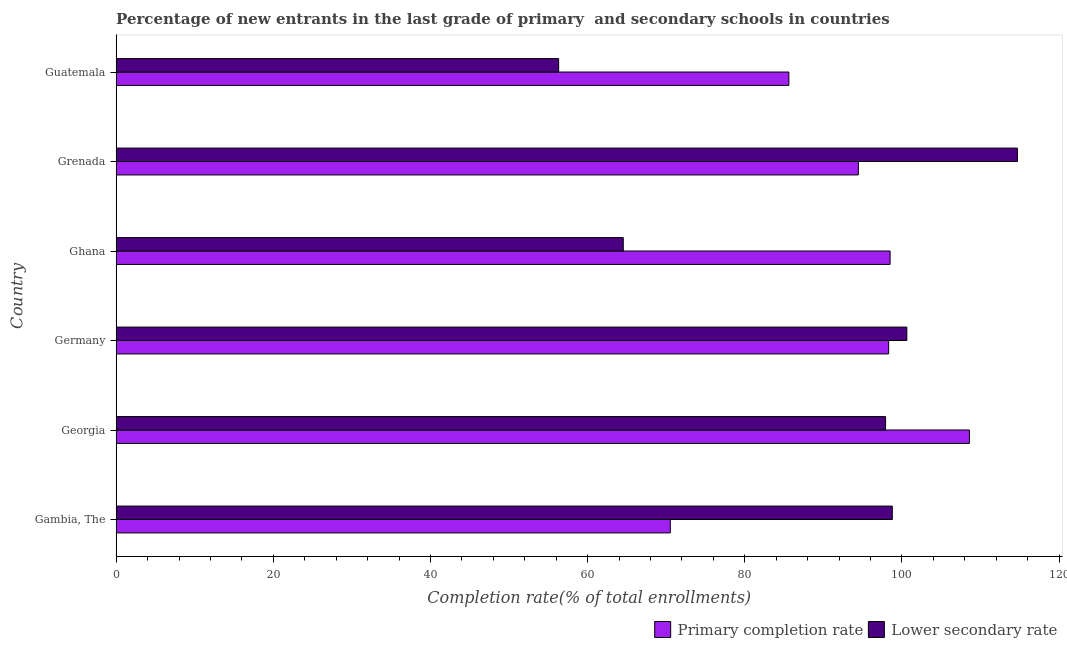How many different coloured bars are there?
Your answer should be compact. 2. Are the number of bars per tick equal to the number of legend labels?
Give a very brief answer. Yes. How many bars are there on the 2nd tick from the bottom?
Provide a short and direct response. 2. What is the label of the 1st group of bars from the top?
Offer a very short reply. Guatemala. What is the completion rate in secondary schools in Georgia?
Your response must be concise. 97.92. Across all countries, what is the maximum completion rate in primary schools?
Your response must be concise. 108.59. Across all countries, what is the minimum completion rate in primary schools?
Provide a short and direct response. 70.52. In which country was the completion rate in primary schools maximum?
Provide a succinct answer. Georgia. In which country was the completion rate in primary schools minimum?
Ensure brevity in your answer.  Gambia, The. What is the total completion rate in primary schools in the graph?
Your answer should be compact. 556. What is the difference between the completion rate in primary schools in Ghana and that in Guatemala?
Provide a short and direct response. 12.88. What is the difference between the completion rate in secondary schools in Grenada and the completion rate in primary schools in Georgia?
Ensure brevity in your answer.  6.11. What is the average completion rate in secondary schools per country?
Ensure brevity in your answer.  88.81. What is the difference between the completion rate in secondary schools and completion rate in primary schools in Georgia?
Make the answer very short. -10.67. What is the ratio of the completion rate in primary schools in Georgia to that in Guatemala?
Your answer should be compact. 1.27. Is the difference between the completion rate in secondary schools in Georgia and Germany greater than the difference between the completion rate in primary schools in Georgia and Germany?
Keep it short and to the point. No. What is the difference between the highest and the second highest completion rate in primary schools?
Your response must be concise. 10.1. What is the difference between the highest and the lowest completion rate in primary schools?
Your answer should be compact. 38.07. In how many countries, is the completion rate in secondary schools greater than the average completion rate in secondary schools taken over all countries?
Offer a terse response. 4. What does the 2nd bar from the top in Grenada represents?
Provide a short and direct response. Primary completion rate. What does the 1st bar from the bottom in Georgia represents?
Your answer should be compact. Primary completion rate. How many bars are there?
Make the answer very short. 12. How many countries are there in the graph?
Your answer should be compact. 6. What is the difference between two consecutive major ticks on the X-axis?
Keep it short and to the point. 20. Does the graph contain any zero values?
Provide a short and direct response. No. Does the graph contain grids?
Your answer should be compact. No. Where does the legend appear in the graph?
Provide a short and direct response. Bottom right. How are the legend labels stacked?
Provide a short and direct response. Horizontal. What is the title of the graph?
Make the answer very short. Percentage of new entrants in the last grade of primary  and secondary schools in countries. What is the label or title of the X-axis?
Keep it short and to the point. Completion rate(% of total enrollments). What is the label or title of the Y-axis?
Your answer should be compact. Country. What is the Completion rate(% of total enrollments) of Primary completion rate in Gambia, The?
Provide a short and direct response. 70.52. What is the Completion rate(% of total enrollments) in Lower secondary rate in Gambia, The?
Give a very brief answer. 98.78. What is the Completion rate(% of total enrollments) of Primary completion rate in Georgia?
Provide a short and direct response. 108.59. What is the Completion rate(% of total enrollments) of Lower secondary rate in Georgia?
Provide a succinct answer. 97.92. What is the Completion rate(% of total enrollments) of Primary completion rate in Germany?
Ensure brevity in your answer.  98.32. What is the Completion rate(% of total enrollments) of Lower secondary rate in Germany?
Keep it short and to the point. 100.63. What is the Completion rate(% of total enrollments) in Primary completion rate in Ghana?
Make the answer very short. 98.5. What is the Completion rate(% of total enrollments) in Lower secondary rate in Ghana?
Provide a short and direct response. 64.54. What is the Completion rate(% of total enrollments) of Primary completion rate in Grenada?
Your response must be concise. 94.46. What is the Completion rate(% of total enrollments) of Lower secondary rate in Grenada?
Make the answer very short. 114.7. What is the Completion rate(% of total enrollments) in Primary completion rate in Guatemala?
Your answer should be very brief. 85.61. What is the Completion rate(% of total enrollments) in Lower secondary rate in Guatemala?
Your answer should be compact. 56.32. Across all countries, what is the maximum Completion rate(% of total enrollments) of Primary completion rate?
Offer a very short reply. 108.59. Across all countries, what is the maximum Completion rate(% of total enrollments) in Lower secondary rate?
Offer a terse response. 114.7. Across all countries, what is the minimum Completion rate(% of total enrollments) in Primary completion rate?
Ensure brevity in your answer.  70.52. Across all countries, what is the minimum Completion rate(% of total enrollments) of Lower secondary rate?
Your answer should be compact. 56.32. What is the total Completion rate(% of total enrollments) of Primary completion rate in the graph?
Your answer should be very brief. 556. What is the total Completion rate(% of total enrollments) in Lower secondary rate in the graph?
Provide a short and direct response. 532.88. What is the difference between the Completion rate(% of total enrollments) of Primary completion rate in Gambia, The and that in Georgia?
Give a very brief answer. -38.07. What is the difference between the Completion rate(% of total enrollments) in Lower secondary rate in Gambia, The and that in Georgia?
Your answer should be compact. 0.86. What is the difference between the Completion rate(% of total enrollments) in Primary completion rate in Gambia, The and that in Germany?
Provide a short and direct response. -27.79. What is the difference between the Completion rate(% of total enrollments) of Lower secondary rate in Gambia, The and that in Germany?
Your response must be concise. -1.85. What is the difference between the Completion rate(% of total enrollments) of Primary completion rate in Gambia, The and that in Ghana?
Provide a succinct answer. -27.97. What is the difference between the Completion rate(% of total enrollments) of Lower secondary rate in Gambia, The and that in Ghana?
Your answer should be compact. 34.24. What is the difference between the Completion rate(% of total enrollments) of Primary completion rate in Gambia, The and that in Grenada?
Provide a short and direct response. -23.94. What is the difference between the Completion rate(% of total enrollments) of Lower secondary rate in Gambia, The and that in Grenada?
Your answer should be compact. -15.92. What is the difference between the Completion rate(% of total enrollments) of Primary completion rate in Gambia, The and that in Guatemala?
Offer a very short reply. -15.09. What is the difference between the Completion rate(% of total enrollments) in Lower secondary rate in Gambia, The and that in Guatemala?
Your answer should be compact. 42.46. What is the difference between the Completion rate(% of total enrollments) in Primary completion rate in Georgia and that in Germany?
Your response must be concise. 10.28. What is the difference between the Completion rate(% of total enrollments) of Lower secondary rate in Georgia and that in Germany?
Make the answer very short. -2.71. What is the difference between the Completion rate(% of total enrollments) in Primary completion rate in Georgia and that in Ghana?
Your answer should be compact. 10.1. What is the difference between the Completion rate(% of total enrollments) in Lower secondary rate in Georgia and that in Ghana?
Give a very brief answer. 33.38. What is the difference between the Completion rate(% of total enrollments) of Primary completion rate in Georgia and that in Grenada?
Keep it short and to the point. 14.13. What is the difference between the Completion rate(% of total enrollments) of Lower secondary rate in Georgia and that in Grenada?
Ensure brevity in your answer.  -16.78. What is the difference between the Completion rate(% of total enrollments) of Primary completion rate in Georgia and that in Guatemala?
Your answer should be compact. 22.98. What is the difference between the Completion rate(% of total enrollments) of Lower secondary rate in Georgia and that in Guatemala?
Offer a very short reply. 41.6. What is the difference between the Completion rate(% of total enrollments) of Primary completion rate in Germany and that in Ghana?
Give a very brief answer. -0.18. What is the difference between the Completion rate(% of total enrollments) of Lower secondary rate in Germany and that in Ghana?
Ensure brevity in your answer.  36.09. What is the difference between the Completion rate(% of total enrollments) of Primary completion rate in Germany and that in Grenada?
Provide a short and direct response. 3.86. What is the difference between the Completion rate(% of total enrollments) in Lower secondary rate in Germany and that in Grenada?
Your answer should be very brief. -14.07. What is the difference between the Completion rate(% of total enrollments) of Primary completion rate in Germany and that in Guatemala?
Your answer should be very brief. 12.7. What is the difference between the Completion rate(% of total enrollments) in Lower secondary rate in Germany and that in Guatemala?
Keep it short and to the point. 44.31. What is the difference between the Completion rate(% of total enrollments) in Primary completion rate in Ghana and that in Grenada?
Your response must be concise. 4.04. What is the difference between the Completion rate(% of total enrollments) of Lower secondary rate in Ghana and that in Grenada?
Keep it short and to the point. -50.16. What is the difference between the Completion rate(% of total enrollments) in Primary completion rate in Ghana and that in Guatemala?
Provide a succinct answer. 12.88. What is the difference between the Completion rate(% of total enrollments) in Lower secondary rate in Ghana and that in Guatemala?
Offer a terse response. 8.22. What is the difference between the Completion rate(% of total enrollments) of Primary completion rate in Grenada and that in Guatemala?
Your answer should be compact. 8.85. What is the difference between the Completion rate(% of total enrollments) in Lower secondary rate in Grenada and that in Guatemala?
Offer a very short reply. 58.38. What is the difference between the Completion rate(% of total enrollments) in Primary completion rate in Gambia, The and the Completion rate(% of total enrollments) in Lower secondary rate in Georgia?
Your answer should be compact. -27.4. What is the difference between the Completion rate(% of total enrollments) of Primary completion rate in Gambia, The and the Completion rate(% of total enrollments) of Lower secondary rate in Germany?
Your answer should be compact. -30.1. What is the difference between the Completion rate(% of total enrollments) of Primary completion rate in Gambia, The and the Completion rate(% of total enrollments) of Lower secondary rate in Ghana?
Offer a terse response. 5.98. What is the difference between the Completion rate(% of total enrollments) of Primary completion rate in Gambia, The and the Completion rate(% of total enrollments) of Lower secondary rate in Grenada?
Your response must be concise. -44.18. What is the difference between the Completion rate(% of total enrollments) of Primary completion rate in Gambia, The and the Completion rate(% of total enrollments) of Lower secondary rate in Guatemala?
Offer a terse response. 14.21. What is the difference between the Completion rate(% of total enrollments) of Primary completion rate in Georgia and the Completion rate(% of total enrollments) of Lower secondary rate in Germany?
Offer a very short reply. 7.96. What is the difference between the Completion rate(% of total enrollments) in Primary completion rate in Georgia and the Completion rate(% of total enrollments) in Lower secondary rate in Ghana?
Offer a terse response. 44.05. What is the difference between the Completion rate(% of total enrollments) in Primary completion rate in Georgia and the Completion rate(% of total enrollments) in Lower secondary rate in Grenada?
Offer a very short reply. -6.11. What is the difference between the Completion rate(% of total enrollments) of Primary completion rate in Georgia and the Completion rate(% of total enrollments) of Lower secondary rate in Guatemala?
Provide a short and direct response. 52.28. What is the difference between the Completion rate(% of total enrollments) of Primary completion rate in Germany and the Completion rate(% of total enrollments) of Lower secondary rate in Ghana?
Offer a terse response. 33.78. What is the difference between the Completion rate(% of total enrollments) of Primary completion rate in Germany and the Completion rate(% of total enrollments) of Lower secondary rate in Grenada?
Provide a succinct answer. -16.38. What is the difference between the Completion rate(% of total enrollments) in Primary completion rate in Germany and the Completion rate(% of total enrollments) in Lower secondary rate in Guatemala?
Make the answer very short. 42. What is the difference between the Completion rate(% of total enrollments) in Primary completion rate in Ghana and the Completion rate(% of total enrollments) in Lower secondary rate in Grenada?
Give a very brief answer. -16.2. What is the difference between the Completion rate(% of total enrollments) of Primary completion rate in Ghana and the Completion rate(% of total enrollments) of Lower secondary rate in Guatemala?
Your answer should be compact. 42.18. What is the difference between the Completion rate(% of total enrollments) in Primary completion rate in Grenada and the Completion rate(% of total enrollments) in Lower secondary rate in Guatemala?
Make the answer very short. 38.14. What is the average Completion rate(% of total enrollments) in Primary completion rate per country?
Your answer should be very brief. 92.67. What is the average Completion rate(% of total enrollments) of Lower secondary rate per country?
Offer a terse response. 88.81. What is the difference between the Completion rate(% of total enrollments) in Primary completion rate and Completion rate(% of total enrollments) in Lower secondary rate in Gambia, The?
Offer a terse response. -28.25. What is the difference between the Completion rate(% of total enrollments) in Primary completion rate and Completion rate(% of total enrollments) in Lower secondary rate in Georgia?
Your answer should be compact. 10.67. What is the difference between the Completion rate(% of total enrollments) of Primary completion rate and Completion rate(% of total enrollments) of Lower secondary rate in Germany?
Make the answer very short. -2.31. What is the difference between the Completion rate(% of total enrollments) of Primary completion rate and Completion rate(% of total enrollments) of Lower secondary rate in Ghana?
Make the answer very short. 33.96. What is the difference between the Completion rate(% of total enrollments) in Primary completion rate and Completion rate(% of total enrollments) in Lower secondary rate in Grenada?
Offer a very short reply. -20.24. What is the difference between the Completion rate(% of total enrollments) in Primary completion rate and Completion rate(% of total enrollments) in Lower secondary rate in Guatemala?
Your answer should be very brief. 29.3. What is the ratio of the Completion rate(% of total enrollments) of Primary completion rate in Gambia, The to that in Georgia?
Offer a terse response. 0.65. What is the ratio of the Completion rate(% of total enrollments) in Lower secondary rate in Gambia, The to that in Georgia?
Make the answer very short. 1.01. What is the ratio of the Completion rate(% of total enrollments) of Primary completion rate in Gambia, The to that in Germany?
Give a very brief answer. 0.72. What is the ratio of the Completion rate(% of total enrollments) of Lower secondary rate in Gambia, The to that in Germany?
Provide a short and direct response. 0.98. What is the ratio of the Completion rate(% of total enrollments) of Primary completion rate in Gambia, The to that in Ghana?
Offer a very short reply. 0.72. What is the ratio of the Completion rate(% of total enrollments) of Lower secondary rate in Gambia, The to that in Ghana?
Keep it short and to the point. 1.53. What is the ratio of the Completion rate(% of total enrollments) in Primary completion rate in Gambia, The to that in Grenada?
Offer a terse response. 0.75. What is the ratio of the Completion rate(% of total enrollments) in Lower secondary rate in Gambia, The to that in Grenada?
Ensure brevity in your answer.  0.86. What is the ratio of the Completion rate(% of total enrollments) of Primary completion rate in Gambia, The to that in Guatemala?
Ensure brevity in your answer.  0.82. What is the ratio of the Completion rate(% of total enrollments) in Lower secondary rate in Gambia, The to that in Guatemala?
Provide a succinct answer. 1.75. What is the ratio of the Completion rate(% of total enrollments) in Primary completion rate in Georgia to that in Germany?
Offer a terse response. 1.1. What is the ratio of the Completion rate(% of total enrollments) in Lower secondary rate in Georgia to that in Germany?
Your response must be concise. 0.97. What is the ratio of the Completion rate(% of total enrollments) of Primary completion rate in Georgia to that in Ghana?
Give a very brief answer. 1.1. What is the ratio of the Completion rate(% of total enrollments) of Lower secondary rate in Georgia to that in Ghana?
Your answer should be very brief. 1.52. What is the ratio of the Completion rate(% of total enrollments) in Primary completion rate in Georgia to that in Grenada?
Offer a terse response. 1.15. What is the ratio of the Completion rate(% of total enrollments) in Lower secondary rate in Georgia to that in Grenada?
Make the answer very short. 0.85. What is the ratio of the Completion rate(% of total enrollments) of Primary completion rate in Georgia to that in Guatemala?
Your answer should be compact. 1.27. What is the ratio of the Completion rate(% of total enrollments) in Lower secondary rate in Georgia to that in Guatemala?
Ensure brevity in your answer.  1.74. What is the ratio of the Completion rate(% of total enrollments) of Lower secondary rate in Germany to that in Ghana?
Provide a succinct answer. 1.56. What is the ratio of the Completion rate(% of total enrollments) in Primary completion rate in Germany to that in Grenada?
Your response must be concise. 1.04. What is the ratio of the Completion rate(% of total enrollments) in Lower secondary rate in Germany to that in Grenada?
Your answer should be very brief. 0.88. What is the ratio of the Completion rate(% of total enrollments) of Primary completion rate in Germany to that in Guatemala?
Your answer should be very brief. 1.15. What is the ratio of the Completion rate(% of total enrollments) of Lower secondary rate in Germany to that in Guatemala?
Offer a very short reply. 1.79. What is the ratio of the Completion rate(% of total enrollments) of Primary completion rate in Ghana to that in Grenada?
Offer a very short reply. 1.04. What is the ratio of the Completion rate(% of total enrollments) of Lower secondary rate in Ghana to that in Grenada?
Your answer should be very brief. 0.56. What is the ratio of the Completion rate(% of total enrollments) in Primary completion rate in Ghana to that in Guatemala?
Provide a short and direct response. 1.15. What is the ratio of the Completion rate(% of total enrollments) of Lower secondary rate in Ghana to that in Guatemala?
Make the answer very short. 1.15. What is the ratio of the Completion rate(% of total enrollments) of Primary completion rate in Grenada to that in Guatemala?
Offer a very short reply. 1.1. What is the ratio of the Completion rate(% of total enrollments) in Lower secondary rate in Grenada to that in Guatemala?
Offer a terse response. 2.04. What is the difference between the highest and the second highest Completion rate(% of total enrollments) in Primary completion rate?
Make the answer very short. 10.1. What is the difference between the highest and the second highest Completion rate(% of total enrollments) in Lower secondary rate?
Offer a very short reply. 14.07. What is the difference between the highest and the lowest Completion rate(% of total enrollments) of Primary completion rate?
Offer a terse response. 38.07. What is the difference between the highest and the lowest Completion rate(% of total enrollments) of Lower secondary rate?
Ensure brevity in your answer.  58.38. 